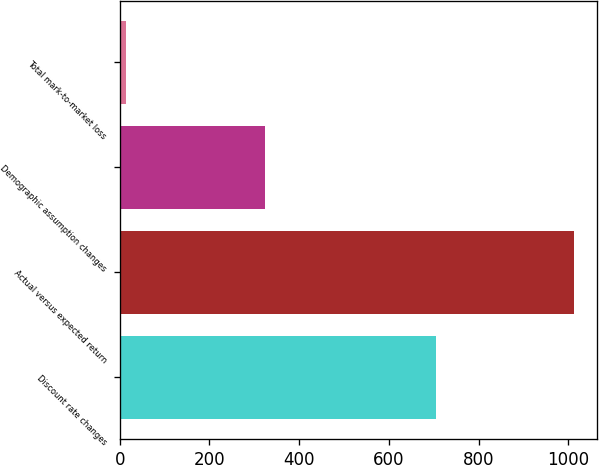Convert chart. <chart><loc_0><loc_0><loc_500><loc_500><bar_chart><fcel>Discount rate changes<fcel>Actual versus expected return<fcel>Demographic assumption changes<fcel>Total mark-to-market loss<nl><fcel>705<fcel>1013<fcel>323<fcel>15<nl></chart> 